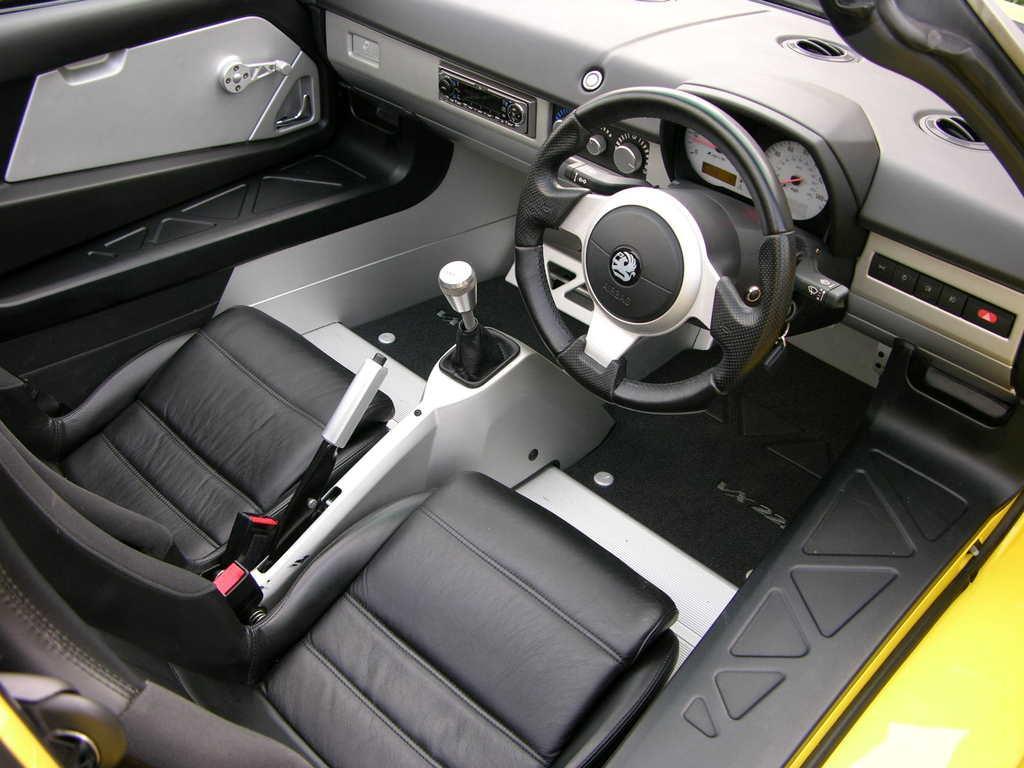Please provide a concise description of this image. In the image we can see inside of the vehicle. 